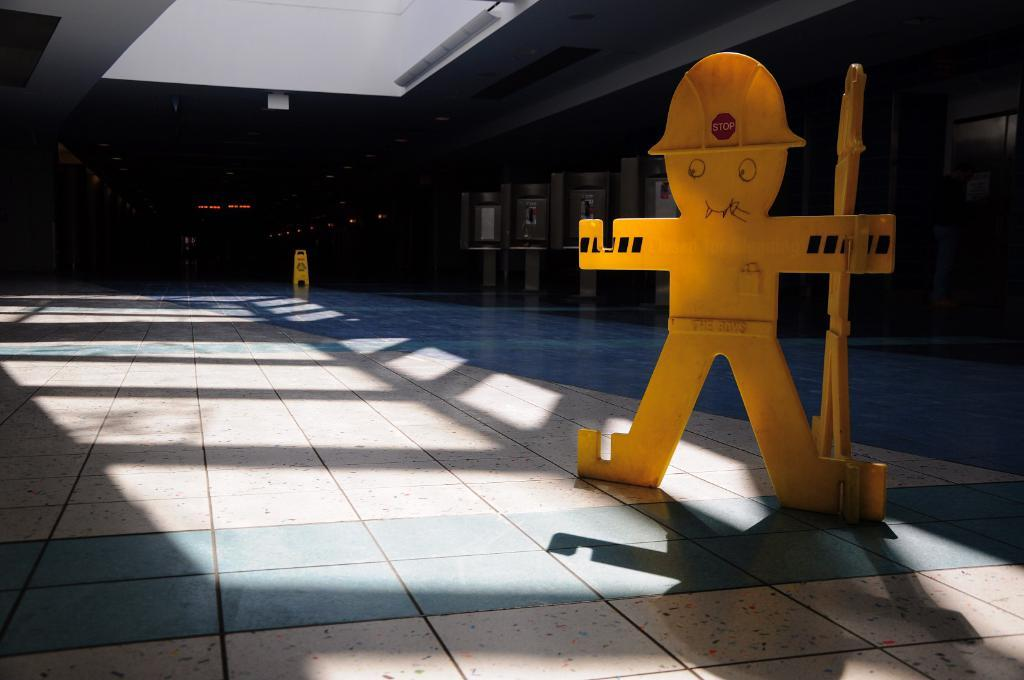What is the main subject of the image? There is a depiction of a person in the image. What type of flooring is visible at the bottom of the image? There is tile flooring at the bottom of the image. What type of attraction can be seen in the image? There is no attraction present in the image; it features a depiction of a person and tile flooring. What type of bird is visible in the image? There is no bird present in the image. 